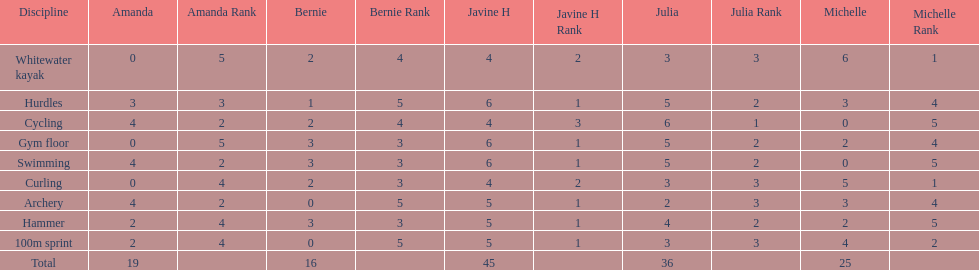What is the first discipline listed on this chart? Whitewater kayak. 